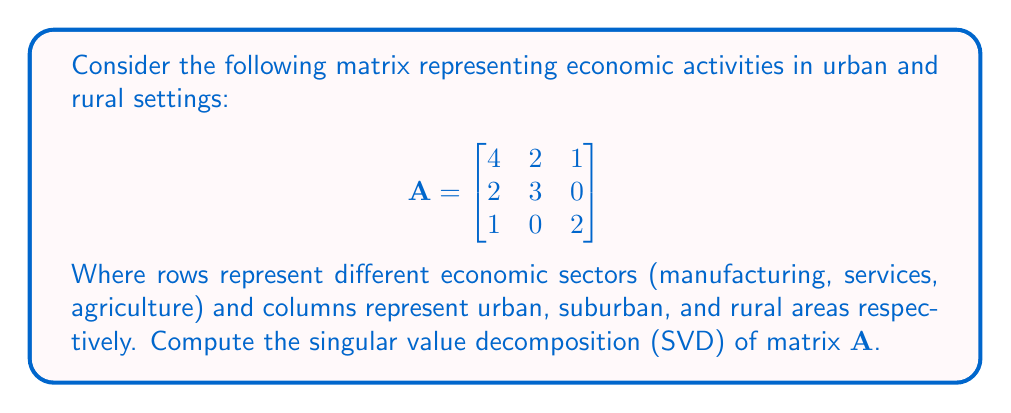Teach me how to tackle this problem. To find the singular value decomposition of matrix A, we need to follow these steps:

1) First, calculate $A^TA$:
   $$A^TA = \begin{bmatrix}
   4 & 2 & 1 \\
   2 & 3 & 0 \\
   1 & 0 & 2
   \end{bmatrix}
   \begin{bmatrix}
   4 & 2 & 1 \\
   2 & 3 & 0 \\
   1 & 0 & 2
   \end{bmatrix}
   = \begin{bmatrix}
   21 & 14 & 6 \\
   14 & 13 & 2 \\
   6 & 2 & 5
   \end{bmatrix}$$

2) Find the eigenvalues of $A^TA$ by solving the characteristic equation:
   $\det(A^TA - \lambda I) = 0$
   $\lambda^3 - 39\lambda^2 + 408\lambda - 1080 = 0$
   The solutions are $\lambda_1 = 30$, $\lambda_2 = 8$, $\lambda_3 = 1$

3) The singular values are the square roots of these eigenvalues:
   $\sigma_1 = \sqrt{30}$, $\sigma_2 = 2\sqrt{2}$, $\sigma_3 = 1$

4) Find the eigenvectors of $A^TA$ corresponding to these eigenvalues. These will form the columns of V:
   For $\lambda_1 = 30$: $v_1 = \frac{1}{\sqrt{14}}[3, 2, 1]^T$
   For $\lambda_2 = 8$:  $v_2 = \frac{1}{\sqrt{14}}[-2, 1, 3]^T$
   For $\lambda_3 = 1$:  $v_3 = \frac{1}{\sqrt{14}}[1, -3, 2]^T$

5) Calculate U using the formula $u_i = \frac{1}{\sigma_i}Av_i$:
   $u_1 = \frac{1}{\sqrt{420}}[10, 7, 3]^T$
   $u_2 = \frac{1}{\sqrt{28}}[-1, 2, -3]^T$
   $u_3 = \frac{1}{\sqrt{14}}[1, -2, 1]^T$

6) The SVD of A is therefore:
   $$A = U\Sigma V^T$$
   Where:
   $$U = \begin{bmatrix}
   \frac{10}{\sqrt{420}} & -\frac{1}{\sqrt{28}} & \frac{1}{\sqrt{14}} \\
   \frac{7}{\sqrt{420}} & \frac{2}{\sqrt{28}} & -\frac{2}{\sqrt{14}} \\
   \frac{3}{\sqrt{420}} & -\frac{3}{\sqrt{28}} & \frac{1}{\sqrt{14}}
   \end{bmatrix}$$

   $$\Sigma = \begin{bmatrix}
   \sqrt{30} & 0 & 0 \\
   0 & 2\sqrt{2} & 0 \\
   0 & 0 & 1
   \end{bmatrix}$$

   $$V = \begin{bmatrix}
   \frac{3}{\sqrt{14}} & -\frac{2}{\sqrt{14}} & \frac{1}{\sqrt{14}} \\
   \frac{2}{\sqrt{14}} & \frac{1}{\sqrt{14}} & -\frac{3}{\sqrt{14}} \\
   \frac{1}{\sqrt{14}} & \frac{3}{\sqrt{14}} & \frac{2}{\sqrt{14}}
   \end{bmatrix}$$
Answer: $A = U\Sigma V^T$, where $U$, $\Sigma$, and $V$ are as given above. 